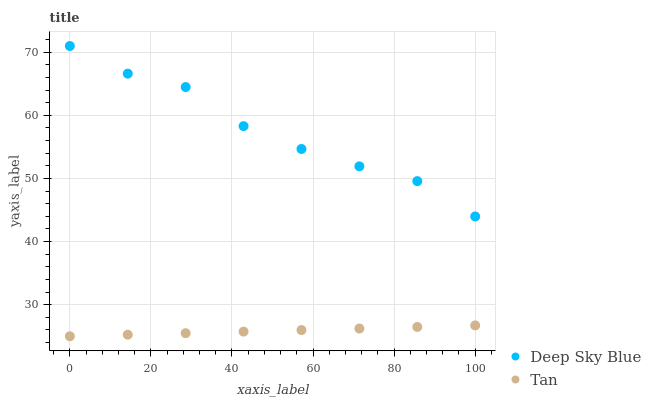Does Tan have the minimum area under the curve?
Answer yes or no. Yes. Does Deep Sky Blue have the maximum area under the curve?
Answer yes or no. Yes. Does Deep Sky Blue have the minimum area under the curve?
Answer yes or no. No. Is Tan the smoothest?
Answer yes or no. Yes. Is Deep Sky Blue the roughest?
Answer yes or no. Yes. Is Deep Sky Blue the smoothest?
Answer yes or no. No. Does Tan have the lowest value?
Answer yes or no. Yes. Does Deep Sky Blue have the lowest value?
Answer yes or no. No. Does Deep Sky Blue have the highest value?
Answer yes or no. Yes. Is Tan less than Deep Sky Blue?
Answer yes or no. Yes. Is Deep Sky Blue greater than Tan?
Answer yes or no. Yes. Does Tan intersect Deep Sky Blue?
Answer yes or no. No. 